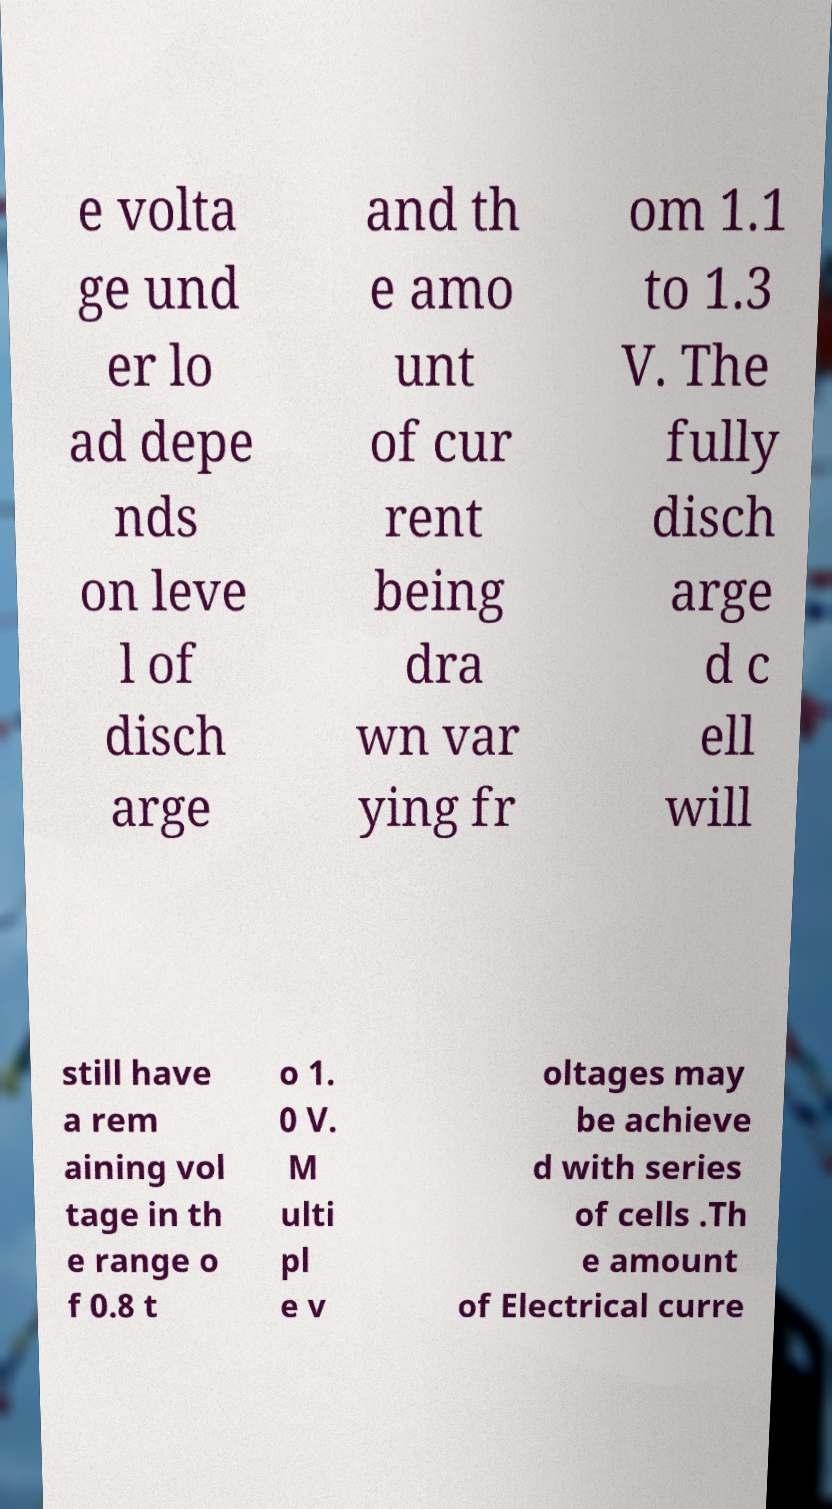Can you read and provide the text displayed in the image?This photo seems to have some interesting text. Can you extract and type it out for me? e volta ge und er lo ad depe nds on leve l of disch arge and th e amo unt of cur rent being dra wn var ying fr om 1.1 to 1.3 V. The fully disch arge d c ell will still have a rem aining vol tage in th e range o f 0.8 t o 1. 0 V. M ulti pl e v oltages may be achieve d with series of cells .Th e amount of Electrical curre 